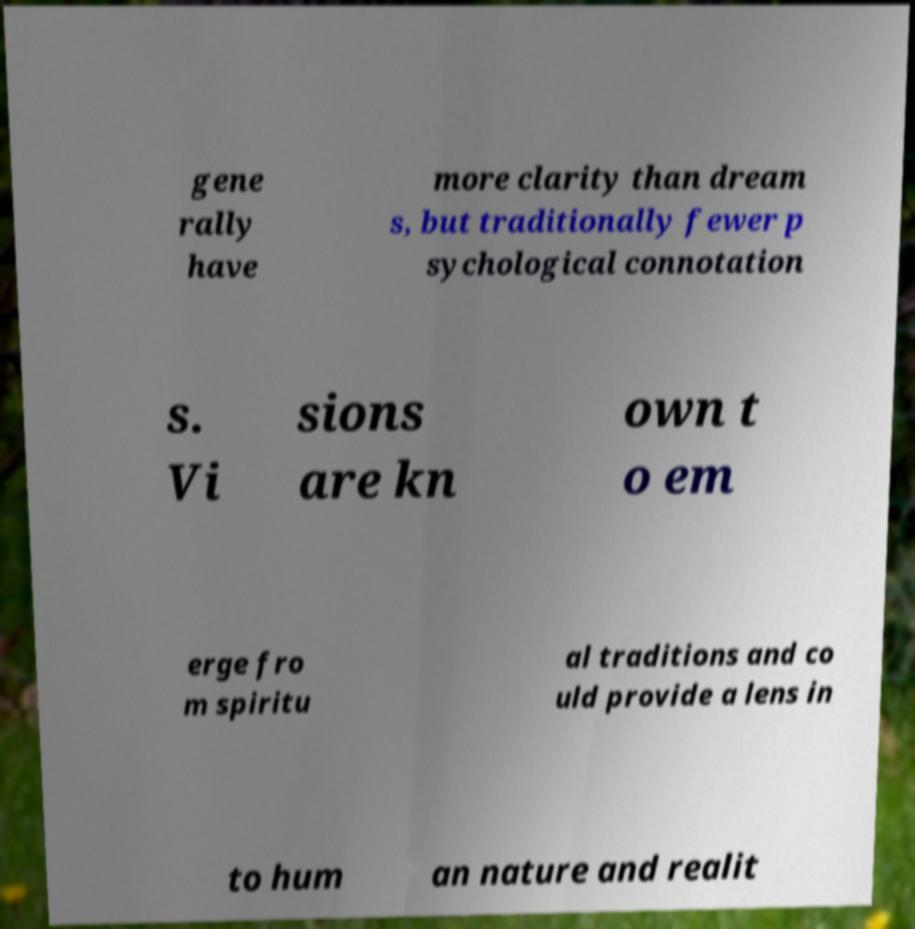What messages or text are displayed in this image? I need them in a readable, typed format. gene rally have more clarity than dream s, but traditionally fewer p sychological connotation s. Vi sions are kn own t o em erge fro m spiritu al traditions and co uld provide a lens in to hum an nature and realit 